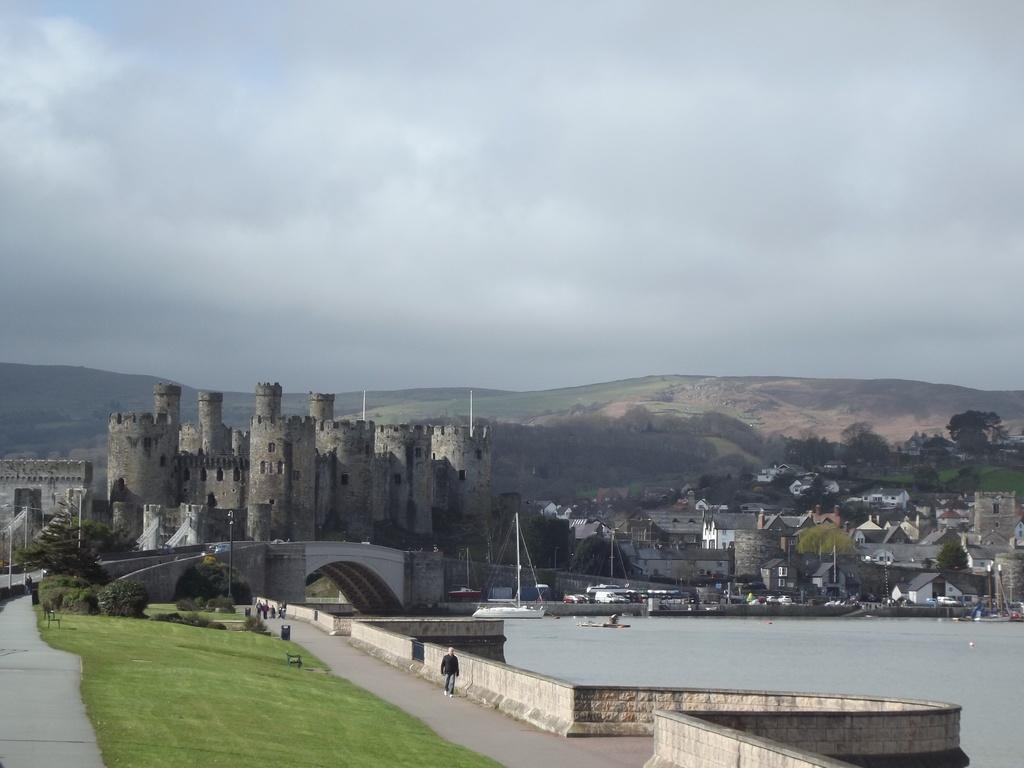In one or two sentences, can you explain what this image depicts? In this image we can see grass on the ground. There is a person walking on the ground. On the right side there is water. In the back there is bridge. Also we can see boats on the water. In the background there are buildings, trees and hills. And there is sky with clouds. 